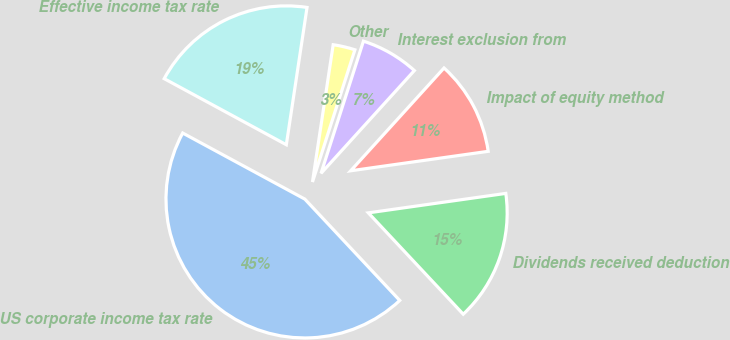Convert chart to OTSL. <chart><loc_0><loc_0><loc_500><loc_500><pie_chart><fcel>US corporate income tax rate<fcel>Dividends received deduction<fcel>Impact of equity method<fcel>Interest exclusion from<fcel>Other<fcel>Effective income tax rate<nl><fcel>44.87%<fcel>15.26%<fcel>11.03%<fcel>6.79%<fcel>2.56%<fcel>19.49%<nl></chart> 